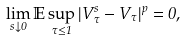<formula> <loc_0><loc_0><loc_500><loc_500>\lim _ { s \downarrow 0 } \mathbb { E } \sup _ { \tau \leq 1 } | V _ { \tau } ^ { s } - V _ { \tau } | ^ { p } = 0 ,</formula> 